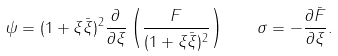<formula> <loc_0><loc_0><loc_500><loc_500>\psi = ( 1 + \xi \bar { \xi } ) ^ { 2 } \frac { \partial } { \partial \xi } \left ( \frac { F } { ( 1 + \xi \bar { \xi } ) ^ { 2 } } \right ) \quad \sigma = - \frac { \partial \bar { F } } { \partial \xi } .</formula> 